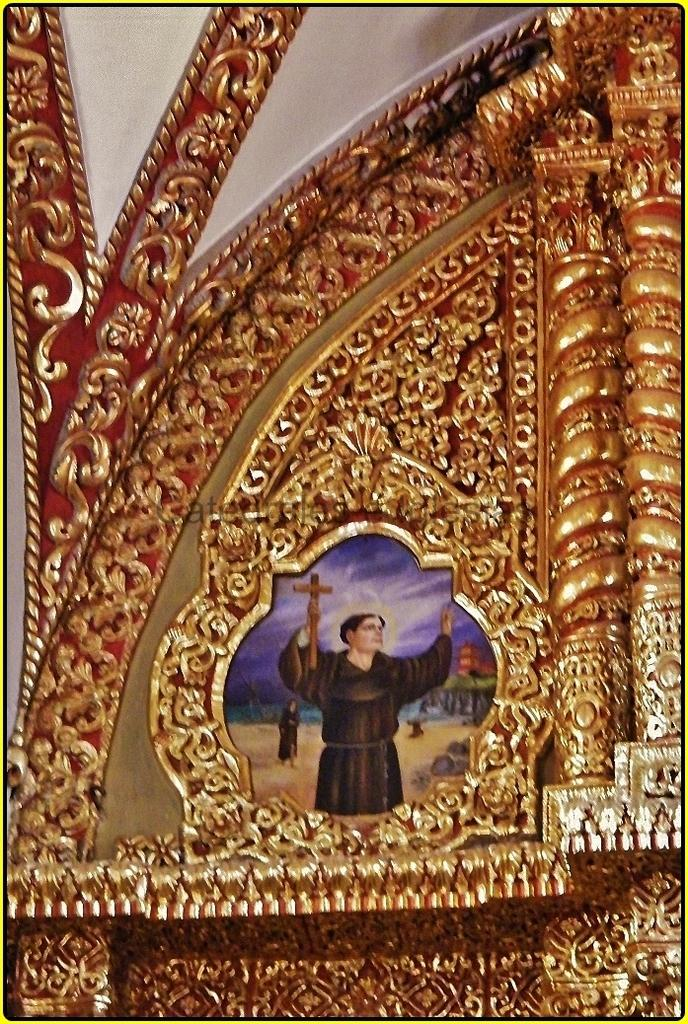What is the main object in the image? There is a decorative frame in the image. What is inside the frame? There is a painting within the frame. What is the subject of the painting? The painting depicts a person holding a holy cross. What color can be seen at the top of the image? The top of the image has a white color. How many cattle are present in the image? There are no cattle present in the image; it features a decorative frame with a painting of a person holding a holy cross. What type of selection process is used to determine the colors in the image? The image does not depict a selection process; it is a static representation of a decorative frame, painting, and the person holding a holy cross. 